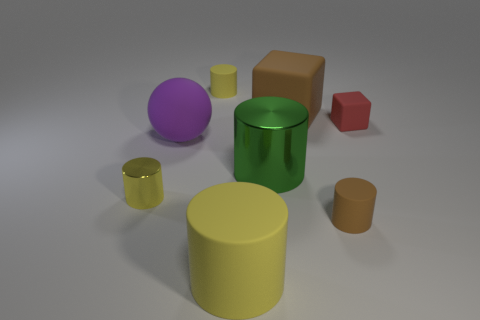Subtract all yellow cylinders. How many were subtracted if there are2yellow cylinders left? 1 Subtract all purple balls. How many yellow cylinders are left? 3 Subtract all brown cylinders. How many cylinders are left? 4 Subtract 1 cylinders. How many cylinders are left? 4 Subtract all small metal cylinders. How many cylinders are left? 4 Subtract all blue cylinders. Subtract all green balls. How many cylinders are left? 5 Add 1 green matte things. How many objects exist? 9 Subtract all balls. How many objects are left? 7 Subtract 0 gray blocks. How many objects are left? 8 Subtract all yellow cylinders. Subtract all green objects. How many objects are left? 4 